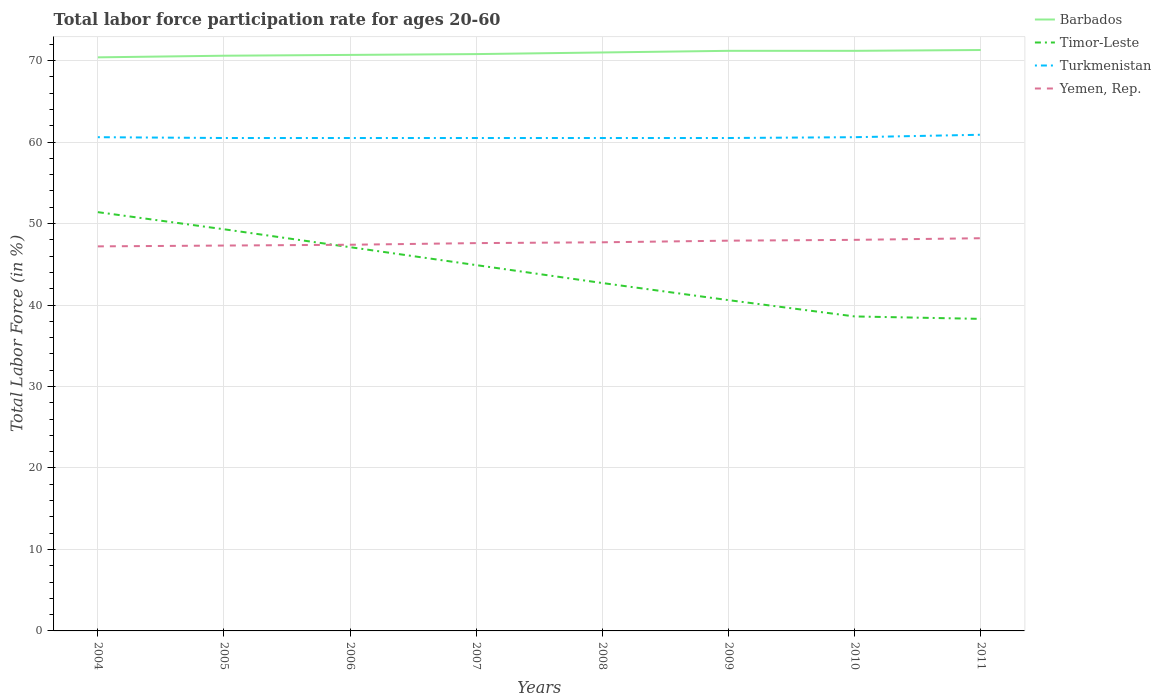How many different coloured lines are there?
Give a very brief answer. 4. Does the line corresponding to Turkmenistan intersect with the line corresponding to Timor-Leste?
Provide a short and direct response. No. Is the number of lines equal to the number of legend labels?
Keep it short and to the point. Yes. Across all years, what is the maximum labor force participation rate in Yemen, Rep.?
Ensure brevity in your answer.  47.2. In which year was the labor force participation rate in Timor-Leste maximum?
Offer a very short reply. 2011. What is the total labor force participation rate in Timor-Leste in the graph?
Provide a succinct answer. 2.2. What is the difference between the highest and the second highest labor force participation rate in Turkmenistan?
Provide a succinct answer. 0.4. What is the difference between the highest and the lowest labor force participation rate in Yemen, Rep.?
Offer a terse response. 4. Is the labor force participation rate in Turkmenistan strictly greater than the labor force participation rate in Yemen, Rep. over the years?
Provide a short and direct response. No. How many lines are there?
Offer a terse response. 4. How many years are there in the graph?
Make the answer very short. 8. What is the difference between two consecutive major ticks on the Y-axis?
Your answer should be compact. 10. Are the values on the major ticks of Y-axis written in scientific E-notation?
Make the answer very short. No. Does the graph contain grids?
Offer a terse response. Yes. Where does the legend appear in the graph?
Make the answer very short. Top right. What is the title of the graph?
Give a very brief answer. Total labor force participation rate for ages 20-60. Does "Chile" appear as one of the legend labels in the graph?
Offer a terse response. No. What is the label or title of the X-axis?
Keep it short and to the point. Years. What is the Total Labor Force (in %) of Barbados in 2004?
Keep it short and to the point. 70.4. What is the Total Labor Force (in %) of Timor-Leste in 2004?
Your answer should be compact. 51.4. What is the Total Labor Force (in %) of Turkmenistan in 2004?
Make the answer very short. 60.6. What is the Total Labor Force (in %) of Yemen, Rep. in 2004?
Ensure brevity in your answer.  47.2. What is the Total Labor Force (in %) in Barbados in 2005?
Your response must be concise. 70.6. What is the Total Labor Force (in %) in Timor-Leste in 2005?
Ensure brevity in your answer.  49.3. What is the Total Labor Force (in %) in Turkmenistan in 2005?
Make the answer very short. 60.5. What is the Total Labor Force (in %) of Yemen, Rep. in 2005?
Provide a succinct answer. 47.3. What is the Total Labor Force (in %) of Barbados in 2006?
Keep it short and to the point. 70.7. What is the Total Labor Force (in %) of Timor-Leste in 2006?
Your response must be concise. 47.1. What is the Total Labor Force (in %) of Turkmenistan in 2006?
Provide a succinct answer. 60.5. What is the Total Labor Force (in %) of Yemen, Rep. in 2006?
Your response must be concise. 47.4. What is the Total Labor Force (in %) of Barbados in 2007?
Your answer should be very brief. 70.8. What is the Total Labor Force (in %) in Timor-Leste in 2007?
Provide a short and direct response. 44.9. What is the Total Labor Force (in %) of Turkmenistan in 2007?
Ensure brevity in your answer.  60.5. What is the Total Labor Force (in %) of Yemen, Rep. in 2007?
Give a very brief answer. 47.6. What is the Total Labor Force (in %) of Barbados in 2008?
Keep it short and to the point. 71. What is the Total Labor Force (in %) of Timor-Leste in 2008?
Your response must be concise. 42.7. What is the Total Labor Force (in %) in Turkmenistan in 2008?
Make the answer very short. 60.5. What is the Total Labor Force (in %) of Yemen, Rep. in 2008?
Your response must be concise. 47.7. What is the Total Labor Force (in %) of Barbados in 2009?
Your answer should be very brief. 71.2. What is the Total Labor Force (in %) in Timor-Leste in 2009?
Your answer should be very brief. 40.6. What is the Total Labor Force (in %) in Turkmenistan in 2009?
Offer a very short reply. 60.5. What is the Total Labor Force (in %) of Yemen, Rep. in 2009?
Provide a short and direct response. 47.9. What is the Total Labor Force (in %) of Barbados in 2010?
Keep it short and to the point. 71.2. What is the Total Labor Force (in %) in Timor-Leste in 2010?
Offer a very short reply. 38.6. What is the Total Labor Force (in %) in Turkmenistan in 2010?
Your answer should be very brief. 60.6. What is the Total Labor Force (in %) in Yemen, Rep. in 2010?
Keep it short and to the point. 48. What is the Total Labor Force (in %) of Barbados in 2011?
Make the answer very short. 71.3. What is the Total Labor Force (in %) in Timor-Leste in 2011?
Give a very brief answer. 38.3. What is the Total Labor Force (in %) of Turkmenistan in 2011?
Give a very brief answer. 60.9. What is the Total Labor Force (in %) in Yemen, Rep. in 2011?
Keep it short and to the point. 48.2. Across all years, what is the maximum Total Labor Force (in %) in Barbados?
Your response must be concise. 71.3. Across all years, what is the maximum Total Labor Force (in %) in Timor-Leste?
Provide a short and direct response. 51.4. Across all years, what is the maximum Total Labor Force (in %) in Turkmenistan?
Provide a succinct answer. 60.9. Across all years, what is the maximum Total Labor Force (in %) of Yemen, Rep.?
Your answer should be compact. 48.2. Across all years, what is the minimum Total Labor Force (in %) in Barbados?
Your answer should be very brief. 70.4. Across all years, what is the minimum Total Labor Force (in %) of Timor-Leste?
Your response must be concise. 38.3. Across all years, what is the minimum Total Labor Force (in %) in Turkmenistan?
Make the answer very short. 60.5. Across all years, what is the minimum Total Labor Force (in %) in Yemen, Rep.?
Provide a succinct answer. 47.2. What is the total Total Labor Force (in %) in Barbados in the graph?
Give a very brief answer. 567.2. What is the total Total Labor Force (in %) of Timor-Leste in the graph?
Provide a succinct answer. 352.9. What is the total Total Labor Force (in %) of Turkmenistan in the graph?
Make the answer very short. 484.6. What is the total Total Labor Force (in %) in Yemen, Rep. in the graph?
Make the answer very short. 381.3. What is the difference between the Total Labor Force (in %) of Timor-Leste in 2004 and that in 2005?
Keep it short and to the point. 2.1. What is the difference between the Total Labor Force (in %) of Barbados in 2004 and that in 2006?
Offer a terse response. -0.3. What is the difference between the Total Labor Force (in %) in Timor-Leste in 2004 and that in 2006?
Provide a short and direct response. 4.3. What is the difference between the Total Labor Force (in %) of Timor-Leste in 2004 and that in 2007?
Provide a short and direct response. 6.5. What is the difference between the Total Labor Force (in %) in Turkmenistan in 2004 and that in 2007?
Ensure brevity in your answer.  0.1. What is the difference between the Total Labor Force (in %) in Yemen, Rep. in 2004 and that in 2007?
Your answer should be compact. -0.4. What is the difference between the Total Labor Force (in %) of Turkmenistan in 2004 and that in 2008?
Your answer should be compact. 0.1. What is the difference between the Total Labor Force (in %) in Yemen, Rep. in 2004 and that in 2008?
Your response must be concise. -0.5. What is the difference between the Total Labor Force (in %) of Barbados in 2004 and that in 2009?
Make the answer very short. -0.8. What is the difference between the Total Labor Force (in %) of Timor-Leste in 2004 and that in 2009?
Make the answer very short. 10.8. What is the difference between the Total Labor Force (in %) in Yemen, Rep. in 2004 and that in 2010?
Give a very brief answer. -0.8. What is the difference between the Total Labor Force (in %) in Barbados in 2004 and that in 2011?
Make the answer very short. -0.9. What is the difference between the Total Labor Force (in %) of Turkmenistan in 2004 and that in 2011?
Your answer should be compact. -0.3. What is the difference between the Total Labor Force (in %) in Barbados in 2005 and that in 2006?
Your answer should be compact. -0.1. What is the difference between the Total Labor Force (in %) in Timor-Leste in 2005 and that in 2006?
Offer a very short reply. 2.2. What is the difference between the Total Labor Force (in %) of Barbados in 2005 and that in 2007?
Make the answer very short. -0.2. What is the difference between the Total Labor Force (in %) in Timor-Leste in 2005 and that in 2007?
Give a very brief answer. 4.4. What is the difference between the Total Labor Force (in %) of Yemen, Rep. in 2005 and that in 2007?
Offer a terse response. -0.3. What is the difference between the Total Labor Force (in %) of Barbados in 2005 and that in 2008?
Provide a short and direct response. -0.4. What is the difference between the Total Labor Force (in %) in Yemen, Rep. in 2005 and that in 2008?
Provide a short and direct response. -0.4. What is the difference between the Total Labor Force (in %) of Turkmenistan in 2005 and that in 2009?
Ensure brevity in your answer.  0. What is the difference between the Total Labor Force (in %) in Timor-Leste in 2005 and that in 2010?
Your answer should be compact. 10.7. What is the difference between the Total Labor Force (in %) in Barbados in 2005 and that in 2011?
Keep it short and to the point. -0.7. What is the difference between the Total Labor Force (in %) in Timor-Leste in 2005 and that in 2011?
Offer a very short reply. 11. What is the difference between the Total Labor Force (in %) in Turkmenistan in 2005 and that in 2011?
Make the answer very short. -0.4. What is the difference between the Total Labor Force (in %) of Yemen, Rep. in 2005 and that in 2011?
Make the answer very short. -0.9. What is the difference between the Total Labor Force (in %) in Barbados in 2006 and that in 2007?
Make the answer very short. -0.1. What is the difference between the Total Labor Force (in %) in Timor-Leste in 2006 and that in 2007?
Offer a terse response. 2.2. What is the difference between the Total Labor Force (in %) of Turkmenistan in 2006 and that in 2007?
Your response must be concise. 0. What is the difference between the Total Labor Force (in %) of Yemen, Rep. in 2006 and that in 2007?
Keep it short and to the point. -0.2. What is the difference between the Total Labor Force (in %) in Barbados in 2006 and that in 2008?
Provide a short and direct response. -0.3. What is the difference between the Total Labor Force (in %) in Turkmenistan in 2006 and that in 2008?
Make the answer very short. 0. What is the difference between the Total Labor Force (in %) in Yemen, Rep. in 2006 and that in 2008?
Give a very brief answer. -0.3. What is the difference between the Total Labor Force (in %) in Barbados in 2006 and that in 2009?
Offer a terse response. -0.5. What is the difference between the Total Labor Force (in %) in Yemen, Rep. in 2006 and that in 2009?
Keep it short and to the point. -0.5. What is the difference between the Total Labor Force (in %) in Turkmenistan in 2006 and that in 2011?
Offer a very short reply. -0.4. What is the difference between the Total Labor Force (in %) of Barbados in 2007 and that in 2008?
Your answer should be compact. -0.2. What is the difference between the Total Labor Force (in %) of Timor-Leste in 2007 and that in 2008?
Offer a terse response. 2.2. What is the difference between the Total Labor Force (in %) of Yemen, Rep. in 2007 and that in 2008?
Keep it short and to the point. -0.1. What is the difference between the Total Labor Force (in %) in Yemen, Rep. in 2007 and that in 2009?
Offer a terse response. -0.3. What is the difference between the Total Labor Force (in %) of Timor-Leste in 2007 and that in 2010?
Provide a short and direct response. 6.3. What is the difference between the Total Labor Force (in %) of Turkmenistan in 2007 and that in 2010?
Provide a succinct answer. -0.1. What is the difference between the Total Labor Force (in %) of Timor-Leste in 2007 and that in 2011?
Your response must be concise. 6.6. What is the difference between the Total Labor Force (in %) of Turkmenistan in 2007 and that in 2011?
Offer a terse response. -0.4. What is the difference between the Total Labor Force (in %) in Turkmenistan in 2008 and that in 2009?
Provide a short and direct response. 0. What is the difference between the Total Labor Force (in %) of Yemen, Rep. in 2008 and that in 2009?
Give a very brief answer. -0.2. What is the difference between the Total Labor Force (in %) in Barbados in 2008 and that in 2010?
Provide a short and direct response. -0.2. What is the difference between the Total Labor Force (in %) in Timor-Leste in 2008 and that in 2010?
Ensure brevity in your answer.  4.1. What is the difference between the Total Labor Force (in %) in Yemen, Rep. in 2008 and that in 2010?
Keep it short and to the point. -0.3. What is the difference between the Total Labor Force (in %) of Barbados in 2008 and that in 2011?
Keep it short and to the point. -0.3. What is the difference between the Total Labor Force (in %) in Timor-Leste in 2008 and that in 2011?
Your response must be concise. 4.4. What is the difference between the Total Labor Force (in %) of Timor-Leste in 2009 and that in 2010?
Ensure brevity in your answer.  2. What is the difference between the Total Labor Force (in %) of Turkmenistan in 2009 and that in 2010?
Provide a short and direct response. -0.1. What is the difference between the Total Labor Force (in %) of Turkmenistan in 2009 and that in 2011?
Provide a short and direct response. -0.4. What is the difference between the Total Labor Force (in %) of Turkmenistan in 2010 and that in 2011?
Offer a terse response. -0.3. What is the difference between the Total Labor Force (in %) of Yemen, Rep. in 2010 and that in 2011?
Your response must be concise. -0.2. What is the difference between the Total Labor Force (in %) in Barbados in 2004 and the Total Labor Force (in %) in Timor-Leste in 2005?
Offer a very short reply. 21.1. What is the difference between the Total Labor Force (in %) of Barbados in 2004 and the Total Labor Force (in %) of Yemen, Rep. in 2005?
Your answer should be very brief. 23.1. What is the difference between the Total Labor Force (in %) of Turkmenistan in 2004 and the Total Labor Force (in %) of Yemen, Rep. in 2005?
Your answer should be very brief. 13.3. What is the difference between the Total Labor Force (in %) of Barbados in 2004 and the Total Labor Force (in %) of Timor-Leste in 2006?
Provide a succinct answer. 23.3. What is the difference between the Total Labor Force (in %) of Barbados in 2004 and the Total Labor Force (in %) of Yemen, Rep. in 2006?
Your answer should be compact. 23. What is the difference between the Total Labor Force (in %) in Timor-Leste in 2004 and the Total Labor Force (in %) in Yemen, Rep. in 2006?
Ensure brevity in your answer.  4. What is the difference between the Total Labor Force (in %) of Barbados in 2004 and the Total Labor Force (in %) of Yemen, Rep. in 2007?
Offer a terse response. 22.8. What is the difference between the Total Labor Force (in %) in Timor-Leste in 2004 and the Total Labor Force (in %) in Turkmenistan in 2007?
Your answer should be compact. -9.1. What is the difference between the Total Labor Force (in %) of Timor-Leste in 2004 and the Total Labor Force (in %) of Yemen, Rep. in 2007?
Your answer should be very brief. 3.8. What is the difference between the Total Labor Force (in %) in Turkmenistan in 2004 and the Total Labor Force (in %) in Yemen, Rep. in 2007?
Your response must be concise. 13. What is the difference between the Total Labor Force (in %) in Barbados in 2004 and the Total Labor Force (in %) in Timor-Leste in 2008?
Provide a succinct answer. 27.7. What is the difference between the Total Labor Force (in %) in Barbados in 2004 and the Total Labor Force (in %) in Turkmenistan in 2008?
Keep it short and to the point. 9.9. What is the difference between the Total Labor Force (in %) in Barbados in 2004 and the Total Labor Force (in %) in Yemen, Rep. in 2008?
Your response must be concise. 22.7. What is the difference between the Total Labor Force (in %) of Timor-Leste in 2004 and the Total Labor Force (in %) of Turkmenistan in 2008?
Offer a very short reply. -9.1. What is the difference between the Total Labor Force (in %) of Turkmenistan in 2004 and the Total Labor Force (in %) of Yemen, Rep. in 2008?
Offer a very short reply. 12.9. What is the difference between the Total Labor Force (in %) in Barbados in 2004 and the Total Labor Force (in %) in Timor-Leste in 2009?
Provide a succinct answer. 29.8. What is the difference between the Total Labor Force (in %) in Turkmenistan in 2004 and the Total Labor Force (in %) in Yemen, Rep. in 2009?
Provide a succinct answer. 12.7. What is the difference between the Total Labor Force (in %) of Barbados in 2004 and the Total Labor Force (in %) of Timor-Leste in 2010?
Your answer should be very brief. 31.8. What is the difference between the Total Labor Force (in %) in Barbados in 2004 and the Total Labor Force (in %) in Yemen, Rep. in 2010?
Offer a terse response. 22.4. What is the difference between the Total Labor Force (in %) in Timor-Leste in 2004 and the Total Labor Force (in %) in Turkmenistan in 2010?
Ensure brevity in your answer.  -9.2. What is the difference between the Total Labor Force (in %) of Timor-Leste in 2004 and the Total Labor Force (in %) of Yemen, Rep. in 2010?
Give a very brief answer. 3.4. What is the difference between the Total Labor Force (in %) of Turkmenistan in 2004 and the Total Labor Force (in %) of Yemen, Rep. in 2010?
Ensure brevity in your answer.  12.6. What is the difference between the Total Labor Force (in %) of Barbados in 2004 and the Total Labor Force (in %) of Timor-Leste in 2011?
Make the answer very short. 32.1. What is the difference between the Total Labor Force (in %) of Barbados in 2004 and the Total Labor Force (in %) of Turkmenistan in 2011?
Provide a succinct answer. 9.5. What is the difference between the Total Labor Force (in %) of Timor-Leste in 2004 and the Total Labor Force (in %) of Yemen, Rep. in 2011?
Your response must be concise. 3.2. What is the difference between the Total Labor Force (in %) in Turkmenistan in 2004 and the Total Labor Force (in %) in Yemen, Rep. in 2011?
Offer a very short reply. 12.4. What is the difference between the Total Labor Force (in %) of Barbados in 2005 and the Total Labor Force (in %) of Turkmenistan in 2006?
Offer a terse response. 10.1. What is the difference between the Total Labor Force (in %) in Barbados in 2005 and the Total Labor Force (in %) in Yemen, Rep. in 2006?
Offer a terse response. 23.2. What is the difference between the Total Labor Force (in %) in Timor-Leste in 2005 and the Total Labor Force (in %) in Yemen, Rep. in 2006?
Your answer should be very brief. 1.9. What is the difference between the Total Labor Force (in %) in Turkmenistan in 2005 and the Total Labor Force (in %) in Yemen, Rep. in 2006?
Make the answer very short. 13.1. What is the difference between the Total Labor Force (in %) of Barbados in 2005 and the Total Labor Force (in %) of Timor-Leste in 2007?
Make the answer very short. 25.7. What is the difference between the Total Labor Force (in %) in Barbados in 2005 and the Total Labor Force (in %) in Turkmenistan in 2007?
Make the answer very short. 10.1. What is the difference between the Total Labor Force (in %) in Timor-Leste in 2005 and the Total Labor Force (in %) in Yemen, Rep. in 2007?
Your answer should be compact. 1.7. What is the difference between the Total Labor Force (in %) in Barbados in 2005 and the Total Labor Force (in %) in Timor-Leste in 2008?
Ensure brevity in your answer.  27.9. What is the difference between the Total Labor Force (in %) in Barbados in 2005 and the Total Labor Force (in %) in Turkmenistan in 2008?
Your answer should be compact. 10.1. What is the difference between the Total Labor Force (in %) in Barbados in 2005 and the Total Labor Force (in %) in Yemen, Rep. in 2008?
Your answer should be compact. 22.9. What is the difference between the Total Labor Force (in %) in Timor-Leste in 2005 and the Total Labor Force (in %) in Turkmenistan in 2008?
Ensure brevity in your answer.  -11.2. What is the difference between the Total Labor Force (in %) of Timor-Leste in 2005 and the Total Labor Force (in %) of Yemen, Rep. in 2008?
Ensure brevity in your answer.  1.6. What is the difference between the Total Labor Force (in %) of Turkmenistan in 2005 and the Total Labor Force (in %) of Yemen, Rep. in 2008?
Your answer should be compact. 12.8. What is the difference between the Total Labor Force (in %) of Barbados in 2005 and the Total Labor Force (in %) of Timor-Leste in 2009?
Your answer should be very brief. 30. What is the difference between the Total Labor Force (in %) in Barbados in 2005 and the Total Labor Force (in %) in Yemen, Rep. in 2009?
Your answer should be very brief. 22.7. What is the difference between the Total Labor Force (in %) in Timor-Leste in 2005 and the Total Labor Force (in %) in Yemen, Rep. in 2009?
Offer a very short reply. 1.4. What is the difference between the Total Labor Force (in %) in Barbados in 2005 and the Total Labor Force (in %) in Yemen, Rep. in 2010?
Your answer should be very brief. 22.6. What is the difference between the Total Labor Force (in %) in Timor-Leste in 2005 and the Total Labor Force (in %) in Turkmenistan in 2010?
Your answer should be very brief. -11.3. What is the difference between the Total Labor Force (in %) of Timor-Leste in 2005 and the Total Labor Force (in %) of Yemen, Rep. in 2010?
Give a very brief answer. 1.3. What is the difference between the Total Labor Force (in %) of Turkmenistan in 2005 and the Total Labor Force (in %) of Yemen, Rep. in 2010?
Your answer should be compact. 12.5. What is the difference between the Total Labor Force (in %) of Barbados in 2005 and the Total Labor Force (in %) of Timor-Leste in 2011?
Keep it short and to the point. 32.3. What is the difference between the Total Labor Force (in %) in Barbados in 2005 and the Total Labor Force (in %) in Turkmenistan in 2011?
Provide a succinct answer. 9.7. What is the difference between the Total Labor Force (in %) of Barbados in 2005 and the Total Labor Force (in %) of Yemen, Rep. in 2011?
Offer a terse response. 22.4. What is the difference between the Total Labor Force (in %) in Timor-Leste in 2005 and the Total Labor Force (in %) in Turkmenistan in 2011?
Offer a very short reply. -11.6. What is the difference between the Total Labor Force (in %) of Timor-Leste in 2005 and the Total Labor Force (in %) of Yemen, Rep. in 2011?
Make the answer very short. 1.1. What is the difference between the Total Labor Force (in %) of Barbados in 2006 and the Total Labor Force (in %) of Timor-Leste in 2007?
Your response must be concise. 25.8. What is the difference between the Total Labor Force (in %) of Barbados in 2006 and the Total Labor Force (in %) of Turkmenistan in 2007?
Give a very brief answer. 10.2. What is the difference between the Total Labor Force (in %) of Barbados in 2006 and the Total Labor Force (in %) of Yemen, Rep. in 2007?
Provide a succinct answer. 23.1. What is the difference between the Total Labor Force (in %) in Turkmenistan in 2006 and the Total Labor Force (in %) in Yemen, Rep. in 2007?
Provide a succinct answer. 12.9. What is the difference between the Total Labor Force (in %) of Barbados in 2006 and the Total Labor Force (in %) of Turkmenistan in 2008?
Make the answer very short. 10.2. What is the difference between the Total Labor Force (in %) in Timor-Leste in 2006 and the Total Labor Force (in %) in Turkmenistan in 2008?
Provide a short and direct response. -13.4. What is the difference between the Total Labor Force (in %) in Timor-Leste in 2006 and the Total Labor Force (in %) in Yemen, Rep. in 2008?
Your answer should be very brief. -0.6. What is the difference between the Total Labor Force (in %) of Turkmenistan in 2006 and the Total Labor Force (in %) of Yemen, Rep. in 2008?
Ensure brevity in your answer.  12.8. What is the difference between the Total Labor Force (in %) in Barbados in 2006 and the Total Labor Force (in %) in Timor-Leste in 2009?
Offer a very short reply. 30.1. What is the difference between the Total Labor Force (in %) in Barbados in 2006 and the Total Labor Force (in %) in Turkmenistan in 2009?
Your answer should be compact. 10.2. What is the difference between the Total Labor Force (in %) in Barbados in 2006 and the Total Labor Force (in %) in Yemen, Rep. in 2009?
Provide a succinct answer. 22.8. What is the difference between the Total Labor Force (in %) in Timor-Leste in 2006 and the Total Labor Force (in %) in Turkmenistan in 2009?
Your answer should be compact. -13.4. What is the difference between the Total Labor Force (in %) of Timor-Leste in 2006 and the Total Labor Force (in %) of Yemen, Rep. in 2009?
Ensure brevity in your answer.  -0.8. What is the difference between the Total Labor Force (in %) of Barbados in 2006 and the Total Labor Force (in %) of Timor-Leste in 2010?
Offer a very short reply. 32.1. What is the difference between the Total Labor Force (in %) of Barbados in 2006 and the Total Labor Force (in %) of Turkmenistan in 2010?
Your answer should be compact. 10.1. What is the difference between the Total Labor Force (in %) in Barbados in 2006 and the Total Labor Force (in %) in Yemen, Rep. in 2010?
Your response must be concise. 22.7. What is the difference between the Total Labor Force (in %) in Barbados in 2006 and the Total Labor Force (in %) in Timor-Leste in 2011?
Offer a terse response. 32.4. What is the difference between the Total Labor Force (in %) of Barbados in 2006 and the Total Labor Force (in %) of Turkmenistan in 2011?
Make the answer very short. 9.8. What is the difference between the Total Labor Force (in %) in Turkmenistan in 2006 and the Total Labor Force (in %) in Yemen, Rep. in 2011?
Provide a succinct answer. 12.3. What is the difference between the Total Labor Force (in %) of Barbados in 2007 and the Total Labor Force (in %) of Timor-Leste in 2008?
Offer a terse response. 28.1. What is the difference between the Total Labor Force (in %) in Barbados in 2007 and the Total Labor Force (in %) in Turkmenistan in 2008?
Your response must be concise. 10.3. What is the difference between the Total Labor Force (in %) of Barbados in 2007 and the Total Labor Force (in %) of Yemen, Rep. in 2008?
Offer a terse response. 23.1. What is the difference between the Total Labor Force (in %) in Timor-Leste in 2007 and the Total Labor Force (in %) in Turkmenistan in 2008?
Offer a terse response. -15.6. What is the difference between the Total Labor Force (in %) of Timor-Leste in 2007 and the Total Labor Force (in %) of Yemen, Rep. in 2008?
Offer a very short reply. -2.8. What is the difference between the Total Labor Force (in %) of Barbados in 2007 and the Total Labor Force (in %) of Timor-Leste in 2009?
Give a very brief answer. 30.2. What is the difference between the Total Labor Force (in %) of Barbados in 2007 and the Total Labor Force (in %) of Turkmenistan in 2009?
Provide a short and direct response. 10.3. What is the difference between the Total Labor Force (in %) of Barbados in 2007 and the Total Labor Force (in %) of Yemen, Rep. in 2009?
Offer a very short reply. 22.9. What is the difference between the Total Labor Force (in %) in Timor-Leste in 2007 and the Total Labor Force (in %) in Turkmenistan in 2009?
Make the answer very short. -15.6. What is the difference between the Total Labor Force (in %) in Turkmenistan in 2007 and the Total Labor Force (in %) in Yemen, Rep. in 2009?
Provide a succinct answer. 12.6. What is the difference between the Total Labor Force (in %) of Barbados in 2007 and the Total Labor Force (in %) of Timor-Leste in 2010?
Give a very brief answer. 32.2. What is the difference between the Total Labor Force (in %) in Barbados in 2007 and the Total Labor Force (in %) in Turkmenistan in 2010?
Provide a succinct answer. 10.2. What is the difference between the Total Labor Force (in %) in Barbados in 2007 and the Total Labor Force (in %) in Yemen, Rep. in 2010?
Offer a terse response. 22.8. What is the difference between the Total Labor Force (in %) in Timor-Leste in 2007 and the Total Labor Force (in %) in Turkmenistan in 2010?
Give a very brief answer. -15.7. What is the difference between the Total Labor Force (in %) of Barbados in 2007 and the Total Labor Force (in %) of Timor-Leste in 2011?
Your answer should be very brief. 32.5. What is the difference between the Total Labor Force (in %) of Barbados in 2007 and the Total Labor Force (in %) of Yemen, Rep. in 2011?
Your response must be concise. 22.6. What is the difference between the Total Labor Force (in %) of Turkmenistan in 2007 and the Total Labor Force (in %) of Yemen, Rep. in 2011?
Keep it short and to the point. 12.3. What is the difference between the Total Labor Force (in %) in Barbados in 2008 and the Total Labor Force (in %) in Timor-Leste in 2009?
Your response must be concise. 30.4. What is the difference between the Total Labor Force (in %) of Barbados in 2008 and the Total Labor Force (in %) of Turkmenistan in 2009?
Provide a short and direct response. 10.5. What is the difference between the Total Labor Force (in %) in Barbados in 2008 and the Total Labor Force (in %) in Yemen, Rep. in 2009?
Your response must be concise. 23.1. What is the difference between the Total Labor Force (in %) of Timor-Leste in 2008 and the Total Labor Force (in %) of Turkmenistan in 2009?
Offer a very short reply. -17.8. What is the difference between the Total Labor Force (in %) in Turkmenistan in 2008 and the Total Labor Force (in %) in Yemen, Rep. in 2009?
Give a very brief answer. 12.6. What is the difference between the Total Labor Force (in %) of Barbados in 2008 and the Total Labor Force (in %) of Timor-Leste in 2010?
Give a very brief answer. 32.4. What is the difference between the Total Labor Force (in %) of Barbados in 2008 and the Total Labor Force (in %) of Turkmenistan in 2010?
Your answer should be compact. 10.4. What is the difference between the Total Labor Force (in %) of Barbados in 2008 and the Total Labor Force (in %) of Yemen, Rep. in 2010?
Keep it short and to the point. 23. What is the difference between the Total Labor Force (in %) in Timor-Leste in 2008 and the Total Labor Force (in %) in Turkmenistan in 2010?
Your answer should be very brief. -17.9. What is the difference between the Total Labor Force (in %) in Timor-Leste in 2008 and the Total Labor Force (in %) in Yemen, Rep. in 2010?
Keep it short and to the point. -5.3. What is the difference between the Total Labor Force (in %) of Barbados in 2008 and the Total Labor Force (in %) of Timor-Leste in 2011?
Provide a short and direct response. 32.7. What is the difference between the Total Labor Force (in %) in Barbados in 2008 and the Total Labor Force (in %) in Yemen, Rep. in 2011?
Your answer should be very brief. 22.8. What is the difference between the Total Labor Force (in %) in Timor-Leste in 2008 and the Total Labor Force (in %) in Turkmenistan in 2011?
Offer a terse response. -18.2. What is the difference between the Total Labor Force (in %) in Timor-Leste in 2008 and the Total Labor Force (in %) in Yemen, Rep. in 2011?
Provide a succinct answer. -5.5. What is the difference between the Total Labor Force (in %) in Barbados in 2009 and the Total Labor Force (in %) in Timor-Leste in 2010?
Give a very brief answer. 32.6. What is the difference between the Total Labor Force (in %) of Barbados in 2009 and the Total Labor Force (in %) of Yemen, Rep. in 2010?
Your response must be concise. 23.2. What is the difference between the Total Labor Force (in %) of Timor-Leste in 2009 and the Total Labor Force (in %) of Turkmenistan in 2010?
Keep it short and to the point. -20. What is the difference between the Total Labor Force (in %) of Turkmenistan in 2009 and the Total Labor Force (in %) of Yemen, Rep. in 2010?
Give a very brief answer. 12.5. What is the difference between the Total Labor Force (in %) of Barbados in 2009 and the Total Labor Force (in %) of Timor-Leste in 2011?
Offer a terse response. 32.9. What is the difference between the Total Labor Force (in %) of Barbados in 2009 and the Total Labor Force (in %) of Yemen, Rep. in 2011?
Provide a succinct answer. 23. What is the difference between the Total Labor Force (in %) in Timor-Leste in 2009 and the Total Labor Force (in %) in Turkmenistan in 2011?
Give a very brief answer. -20.3. What is the difference between the Total Labor Force (in %) in Timor-Leste in 2009 and the Total Labor Force (in %) in Yemen, Rep. in 2011?
Make the answer very short. -7.6. What is the difference between the Total Labor Force (in %) of Barbados in 2010 and the Total Labor Force (in %) of Timor-Leste in 2011?
Provide a succinct answer. 32.9. What is the difference between the Total Labor Force (in %) of Timor-Leste in 2010 and the Total Labor Force (in %) of Turkmenistan in 2011?
Your response must be concise. -22.3. What is the difference between the Total Labor Force (in %) of Timor-Leste in 2010 and the Total Labor Force (in %) of Yemen, Rep. in 2011?
Your response must be concise. -9.6. What is the average Total Labor Force (in %) in Barbados per year?
Your answer should be compact. 70.9. What is the average Total Labor Force (in %) in Timor-Leste per year?
Ensure brevity in your answer.  44.11. What is the average Total Labor Force (in %) in Turkmenistan per year?
Your response must be concise. 60.58. What is the average Total Labor Force (in %) of Yemen, Rep. per year?
Offer a very short reply. 47.66. In the year 2004, what is the difference between the Total Labor Force (in %) in Barbados and Total Labor Force (in %) in Timor-Leste?
Offer a very short reply. 19. In the year 2004, what is the difference between the Total Labor Force (in %) in Barbados and Total Labor Force (in %) in Yemen, Rep.?
Keep it short and to the point. 23.2. In the year 2004, what is the difference between the Total Labor Force (in %) in Turkmenistan and Total Labor Force (in %) in Yemen, Rep.?
Your answer should be compact. 13.4. In the year 2005, what is the difference between the Total Labor Force (in %) of Barbados and Total Labor Force (in %) of Timor-Leste?
Keep it short and to the point. 21.3. In the year 2005, what is the difference between the Total Labor Force (in %) in Barbados and Total Labor Force (in %) in Turkmenistan?
Your response must be concise. 10.1. In the year 2005, what is the difference between the Total Labor Force (in %) in Barbados and Total Labor Force (in %) in Yemen, Rep.?
Your answer should be very brief. 23.3. In the year 2005, what is the difference between the Total Labor Force (in %) of Timor-Leste and Total Labor Force (in %) of Turkmenistan?
Keep it short and to the point. -11.2. In the year 2005, what is the difference between the Total Labor Force (in %) in Timor-Leste and Total Labor Force (in %) in Yemen, Rep.?
Your response must be concise. 2. In the year 2005, what is the difference between the Total Labor Force (in %) in Turkmenistan and Total Labor Force (in %) in Yemen, Rep.?
Your response must be concise. 13.2. In the year 2006, what is the difference between the Total Labor Force (in %) in Barbados and Total Labor Force (in %) in Timor-Leste?
Your answer should be compact. 23.6. In the year 2006, what is the difference between the Total Labor Force (in %) in Barbados and Total Labor Force (in %) in Turkmenistan?
Keep it short and to the point. 10.2. In the year 2006, what is the difference between the Total Labor Force (in %) in Barbados and Total Labor Force (in %) in Yemen, Rep.?
Ensure brevity in your answer.  23.3. In the year 2006, what is the difference between the Total Labor Force (in %) of Timor-Leste and Total Labor Force (in %) of Yemen, Rep.?
Provide a short and direct response. -0.3. In the year 2006, what is the difference between the Total Labor Force (in %) of Turkmenistan and Total Labor Force (in %) of Yemen, Rep.?
Your response must be concise. 13.1. In the year 2007, what is the difference between the Total Labor Force (in %) of Barbados and Total Labor Force (in %) of Timor-Leste?
Make the answer very short. 25.9. In the year 2007, what is the difference between the Total Labor Force (in %) in Barbados and Total Labor Force (in %) in Yemen, Rep.?
Provide a succinct answer. 23.2. In the year 2007, what is the difference between the Total Labor Force (in %) in Timor-Leste and Total Labor Force (in %) in Turkmenistan?
Your answer should be very brief. -15.6. In the year 2008, what is the difference between the Total Labor Force (in %) of Barbados and Total Labor Force (in %) of Timor-Leste?
Offer a very short reply. 28.3. In the year 2008, what is the difference between the Total Labor Force (in %) of Barbados and Total Labor Force (in %) of Turkmenistan?
Provide a succinct answer. 10.5. In the year 2008, what is the difference between the Total Labor Force (in %) of Barbados and Total Labor Force (in %) of Yemen, Rep.?
Your answer should be compact. 23.3. In the year 2008, what is the difference between the Total Labor Force (in %) of Timor-Leste and Total Labor Force (in %) of Turkmenistan?
Keep it short and to the point. -17.8. In the year 2009, what is the difference between the Total Labor Force (in %) of Barbados and Total Labor Force (in %) of Timor-Leste?
Your answer should be compact. 30.6. In the year 2009, what is the difference between the Total Labor Force (in %) of Barbados and Total Labor Force (in %) of Yemen, Rep.?
Your answer should be compact. 23.3. In the year 2009, what is the difference between the Total Labor Force (in %) of Timor-Leste and Total Labor Force (in %) of Turkmenistan?
Your response must be concise. -19.9. In the year 2009, what is the difference between the Total Labor Force (in %) in Turkmenistan and Total Labor Force (in %) in Yemen, Rep.?
Provide a succinct answer. 12.6. In the year 2010, what is the difference between the Total Labor Force (in %) of Barbados and Total Labor Force (in %) of Timor-Leste?
Make the answer very short. 32.6. In the year 2010, what is the difference between the Total Labor Force (in %) in Barbados and Total Labor Force (in %) in Yemen, Rep.?
Give a very brief answer. 23.2. In the year 2010, what is the difference between the Total Labor Force (in %) of Timor-Leste and Total Labor Force (in %) of Yemen, Rep.?
Ensure brevity in your answer.  -9.4. In the year 2011, what is the difference between the Total Labor Force (in %) of Barbados and Total Labor Force (in %) of Timor-Leste?
Provide a succinct answer. 33. In the year 2011, what is the difference between the Total Labor Force (in %) of Barbados and Total Labor Force (in %) of Turkmenistan?
Give a very brief answer. 10.4. In the year 2011, what is the difference between the Total Labor Force (in %) in Barbados and Total Labor Force (in %) in Yemen, Rep.?
Offer a very short reply. 23.1. In the year 2011, what is the difference between the Total Labor Force (in %) in Timor-Leste and Total Labor Force (in %) in Turkmenistan?
Give a very brief answer. -22.6. What is the ratio of the Total Labor Force (in %) of Barbados in 2004 to that in 2005?
Provide a succinct answer. 1. What is the ratio of the Total Labor Force (in %) of Timor-Leste in 2004 to that in 2005?
Keep it short and to the point. 1.04. What is the ratio of the Total Labor Force (in %) in Yemen, Rep. in 2004 to that in 2005?
Your response must be concise. 1. What is the ratio of the Total Labor Force (in %) in Barbados in 2004 to that in 2006?
Your answer should be very brief. 1. What is the ratio of the Total Labor Force (in %) in Timor-Leste in 2004 to that in 2006?
Your answer should be very brief. 1.09. What is the ratio of the Total Labor Force (in %) of Turkmenistan in 2004 to that in 2006?
Offer a terse response. 1. What is the ratio of the Total Labor Force (in %) in Timor-Leste in 2004 to that in 2007?
Offer a very short reply. 1.14. What is the ratio of the Total Labor Force (in %) of Turkmenistan in 2004 to that in 2007?
Provide a short and direct response. 1. What is the ratio of the Total Labor Force (in %) in Barbados in 2004 to that in 2008?
Your answer should be compact. 0.99. What is the ratio of the Total Labor Force (in %) of Timor-Leste in 2004 to that in 2008?
Offer a terse response. 1.2. What is the ratio of the Total Labor Force (in %) in Timor-Leste in 2004 to that in 2009?
Offer a terse response. 1.27. What is the ratio of the Total Labor Force (in %) in Yemen, Rep. in 2004 to that in 2009?
Make the answer very short. 0.99. What is the ratio of the Total Labor Force (in %) of Barbados in 2004 to that in 2010?
Keep it short and to the point. 0.99. What is the ratio of the Total Labor Force (in %) in Timor-Leste in 2004 to that in 2010?
Keep it short and to the point. 1.33. What is the ratio of the Total Labor Force (in %) in Turkmenistan in 2004 to that in 2010?
Provide a succinct answer. 1. What is the ratio of the Total Labor Force (in %) in Yemen, Rep. in 2004 to that in 2010?
Make the answer very short. 0.98. What is the ratio of the Total Labor Force (in %) in Barbados in 2004 to that in 2011?
Keep it short and to the point. 0.99. What is the ratio of the Total Labor Force (in %) of Timor-Leste in 2004 to that in 2011?
Offer a very short reply. 1.34. What is the ratio of the Total Labor Force (in %) of Yemen, Rep. in 2004 to that in 2011?
Your response must be concise. 0.98. What is the ratio of the Total Labor Force (in %) in Timor-Leste in 2005 to that in 2006?
Offer a terse response. 1.05. What is the ratio of the Total Labor Force (in %) of Turkmenistan in 2005 to that in 2006?
Offer a very short reply. 1. What is the ratio of the Total Labor Force (in %) in Yemen, Rep. in 2005 to that in 2006?
Provide a succinct answer. 1. What is the ratio of the Total Labor Force (in %) in Barbados in 2005 to that in 2007?
Ensure brevity in your answer.  1. What is the ratio of the Total Labor Force (in %) in Timor-Leste in 2005 to that in 2007?
Ensure brevity in your answer.  1.1. What is the ratio of the Total Labor Force (in %) of Yemen, Rep. in 2005 to that in 2007?
Offer a terse response. 0.99. What is the ratio of the Total Labor Force (in %) of Barbados in 2005 to that in 2008?
Your response must be concise. 0.99. What is the ratio of the Total Labor Force (in %) in Timor-Leste in 2005 to that in 2008?
Provide a short and direct response. 1.15. What is the ratio of the Total Labor Force (in %) of Barbados in 2005 to that in 2009?
Provide a short and direct response. 0.99. What is the ratio of the Total Labor Force (in %) in Timor-Leste in 2005 to that in 2009?
Your answer should be compact. 1.21. What is the ratio of the Total Labor Force (in %) in Turkmenistan in 2005 to that in 2009?
Your answer should be compact. 1. What is the ratio of the Total Labor Force (in %) of Yemen, Rep. in 2005 to that in 2009?
Offer a very short reply. 0.99. What is the ratio of the Total Labor Force (in %) in Barbados in 2005 to that in 2010?
Your answer should be very brief. 0.99. What is the ratio of the Total Labor Force (in %) of Timor-Leste in 2005 to that in 2010?
Make the answer very short. 1.28. What is the ratio of the Total Labor Force (in %) in Turkmenistan in 2005 to that in 2010?
Provide a short and direct response. 1. What is the ratio of the Total Labor Force (in %) of Yemen, Rep. in 2005 to that in 2010?
Make the answer very short. 0.99. What is the ratio of the Total Labor Force (in %) in Barbados in 2005 to that in 2011?
Your answer should be very brief. 0.99. What is the ratio of the Total Labor Force (in %) in Timor-Leste in 2005 to that in 2011?
Offer a very short reply. 1.29. What is the ratio of the Total Labor Force (in %) in Turkmenistan in 2005 to that in 2011?
Your answer should be very brief. 0.99. What is the ratio of the Total Labor Force (in %) of Yemen, Rep. in 2005 to that in 2011?
Make the answer very short. 0.98. What is the ratio of the Total Labor Force (in %) in Timor-Leste in 2006 to that in 2007?
Provide a succinct answer. 1.05. What is the ratio of the Total Labor Force (in %) in Yemen, Rep. in 2006 to that in 2007?
Make the answer very short. 1. What is the ratio of the Total Labor Force (in %) of Barbados in 2006 to that in 2008?
Your answer should be compact. 1. What is the ratio of the Total Labor Force (in %) of Timor-Leste in 2006 to that in 2008?
Your response must be concise. 1.1. What is the ratio of the Total Labor Force (in %) of Turkmenistan in 2006 to that in 2008?
Offer a terse response. 1. What is the ratio of the Total Labor Force (in %) in Barbados in 2006 to that in 2009?
Offer a terse response. 0.99. What is the ratio of the Total Labor Force (in %) in Timor-Leste in 2006 to that in 2009?
Make the answer very short. 1.16. What is the ratio of the Total Labor Force (in %) of Yemen, Rep. in 2006 to that in 2009?
Give a very brief answer. 0.99. What is the ratio of the Total Labor Force (in %) of Timor-Leste in 2006 to that in 2010?
Provide a short and direct response. 1.22. What is the ratio of the Total Labor Force (in %) of Turkmenistan in 2006 to that in 2010?
Your answer should be very brief. 1. What is the ratio of the Total Labor Force (in %) of Yemen, Rep. in 2006 to that in 2010?
Give a very brief answer. 0.99. What is the ratio of the Total Labor Force (in %) of Timor-Leste in 2006 to that in 2011?
Make the answer very short. 1.23. What is the ratio of the Total Labor Force (in %) in Turkmenistan in 2006 to that in 2011?
Provide a short and direct response. 0.99. What is the ratio of the Total Labor Force (in %) in Yemen, Rep. in 2006 to that in 2011?
Your answer should be very brief. 0.98. What is the ratio of the Total Labor Force (in %) of Timor-Leste in 2007 to that in 2008?
Make the answer very short. 1.05. What is the ratio of the Total Labor Force (in %) in Turkmenistan in 2007 to that in 2008?
Provide a succinct answer. 1. What is the ratio of the Total Labor Force (in %) of Yemen, Rep. in 2007 to that in 2008?
Make the answer very short. 1. What is the ratio of the Total Labor Force (in %) in Barbados in 2007 to that in 2009?
Your answer should be compact. 0.99. What is the ratio of the Total Labor Force (in %) of Timor-Leste in 2007 to that in 2009?
Ensure brevity in your answer.  1.11. What is the ratio of the Total Labor Force (in %) of Barbados in 2007 to that in 2010?
Your response must be concise. 0.99. What is the ratio of the Total Labor Force (in %) of Timor-Leste in 2007 to that in 2010?
Your answer should be very brief. 1.16. What is the ratio of the Total Labor Force (in %) in Yemen, Rep. in 2007 to that in 2010?
Keep it short and to the point. 0.99. What is the ratio of the Total Labor Force (in %) in Barbados in 2007 to that in 2011?
Your answer should be compact. 0.99. What is the ratio of the Total Labor Force (in %) in Timor-Leste in 2007 to that in 2011?
Provide a succinct answer. 1.17. What is the ratio of the Total Labor Force (in %) of Yemen, Rep. in 2007 to that in 2011?
Provide a succinct answer. 0.99. What is the ratio of the Total Labor Force (in %) of Timor-Leste in 2008 to that in 2009?
Keep it short and to the point. 1.05. What is the ratio of the Total Labor Force (in %) in Turkmenistan in 2008 to that in 2009?
Your answer should be very brief. 1. What is the ratio of the Total Labor Force (in %) of Yemen, Rep. in 2008 to that in 2009?
Your answer should be compact. 1. What is the ratio of the Total Labor Force (in %) of Barbados in 2008 to that in 2010?
Provide a short and direct response. 1. What is the ratio of the Total Labor Force (in %) in Timor-Leste in 2008 to that in 2010?
Your response must be concise. 1.11. What is the ratio of the Total Labor Force (in %) of Timor-Leste in 2008 to that in 2011?
Your response must be concise. 1.11. What is the ratio of the Total Labor Force (in %) of Turkmenistan in 2008 to that in 2011?
Your response must be concise. 0.99. What is the ratio of the Total Labor Force (in %) in Yemen, Rep. in 2008 to that in 2011?
Give a very brief answer. 0.99. What is the ratio of the Total Labor Force (in %) of Timor-Leste in 2009 to that in 2010?
Provide a short and direct response. 1.05. What is the ratio of the Total Labor Force (in %) in Timor-Leste in 2009 to that in 2011?
Provide a short and direct response. 1.06. What is the ratio of the Total Labor Force (in %) in Turkmenistan in 2009 to that in 2011?
Offer a terse response. 0.99. What is the ratio of the Total Labor Force (in %) of Turkmenistan in 2010 to that in 2011?
Ensure brevity in your answer.  1. What is the difference between the highest and the second highest Total Labor Force (in %) of Turkmenistan?
Give a very brief answer. 0.3. What is the difference between the highest and the second highest Total Labor Force (in %) in Yemen, Rep.?
Provide a short and direct response. 0.2. What is the difference between the highest and the lowest Total Labor Force (in %) of Turkmenistan?
Your answer should be very brief. 0.4. 